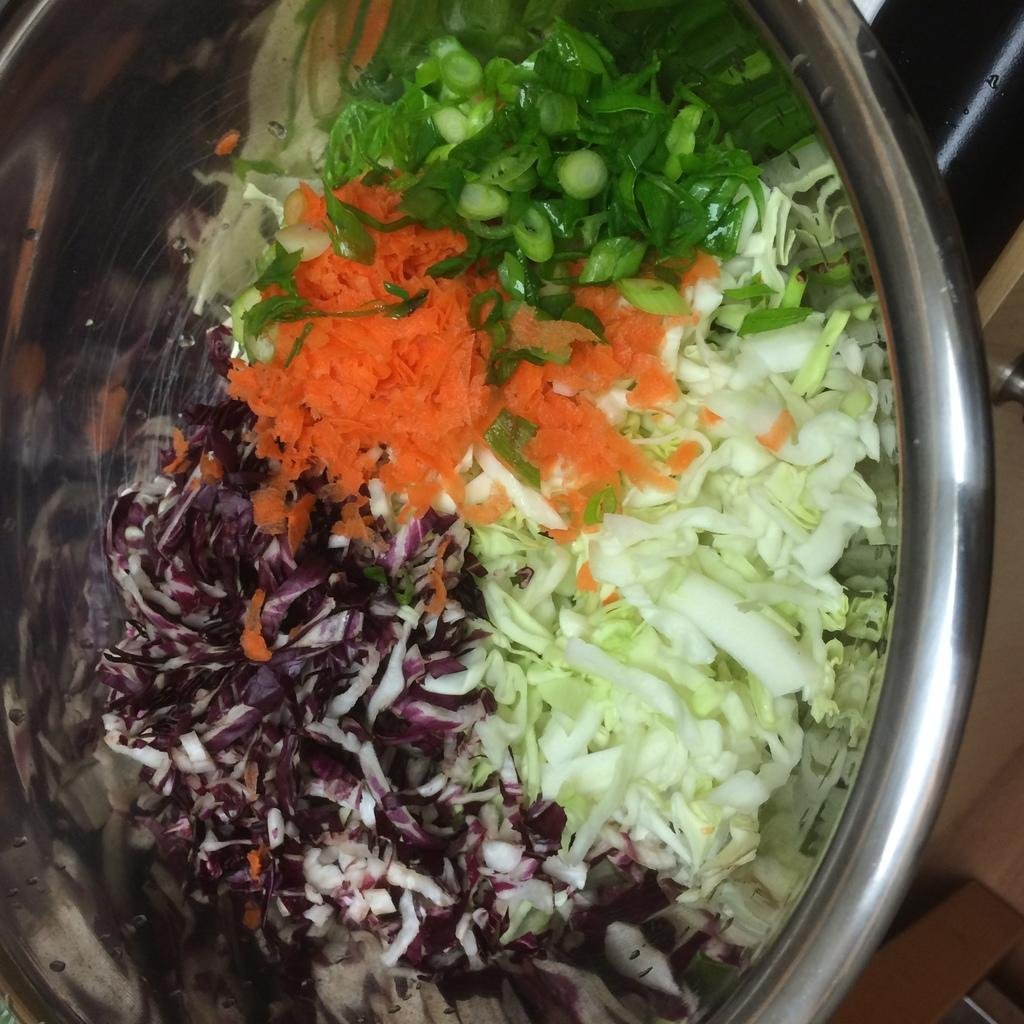What type of food can be seen in the image? There are vegetables in the image. How are the vegetables prepared? The vegetables are cut. What is the container for the cut vegetables? The vegetables are kept in a steel bowl. Where is the steel bowl placed? The steel bowl is placed on a surface. What type of floor is visible in the image? There is a floor visible in the image. What type of furniture can be seen in the image? There are wooden drawers in the image. Is there a throne in the image? No, there is no throne present in the image. Can the vegetables be seen changing colors in the image? No, the vegetables do not change colors in the image; they are simply cut and kept in a steel bowl. 